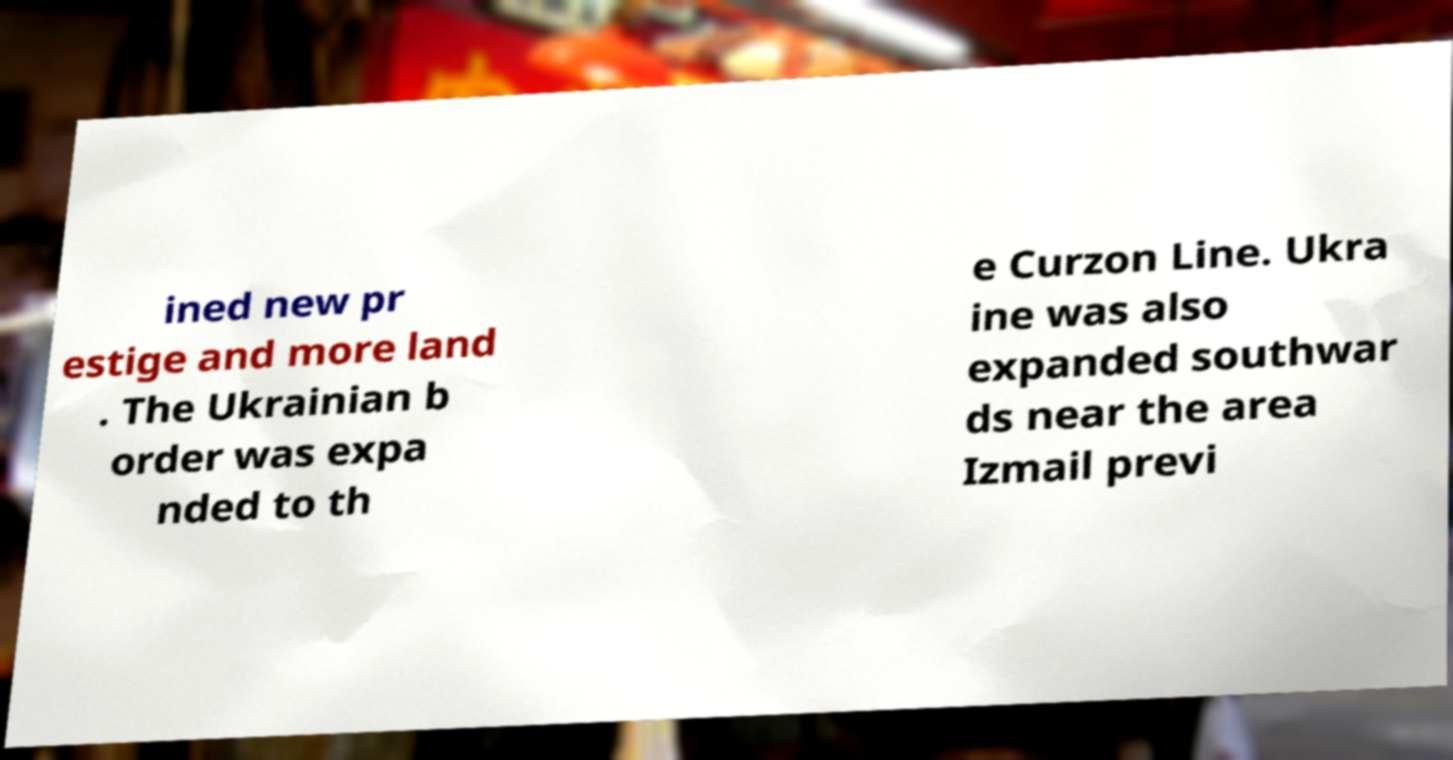Can you accurately transcribe the text from the provided image for me? ined new pr estige and more land . The Ukrainian b order was expa nded to th e Curzon Line. Ukra ine was also expanded southwar ds near the area Izmail previ 